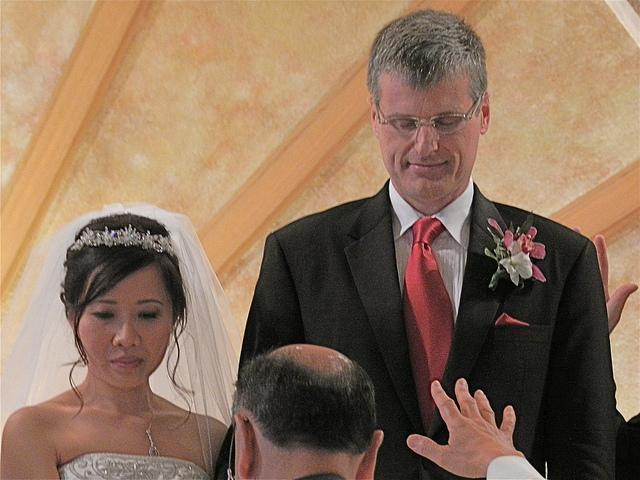How many people are wearing glasses?
Give a very brief answer. 1. How many people are in the picture?
Give a very brief answer. 3. How many bears are there?
Give a very brief answer. 0. 